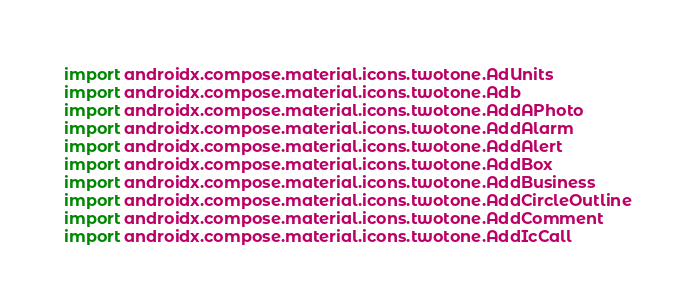<code> <loc_0><loc_0><loc_500><loc_500><_Kotlin_>import androidx.compose.material.icons.twotone.AdUnits
import androidx.compose.material.icons.twotone.Adb
import androidx.compose.material.icons.twotone.AddAPhoto
import androidx.compose.material.icons.twotone.AddAlarm
import androidx.compose.material.icons.twotone.AddAlert
import androidx.compose.material.icons.twotone.AddBox
import androidx.compose.material.icons.twotone.AddBusiness
import androidx.compose.material.icons.twotone.AddCircleOutline
import androidx.compose.material.icons.twotone.AddComment
import androidx.compose.material.icons.twotone.AddIcCall</code> 